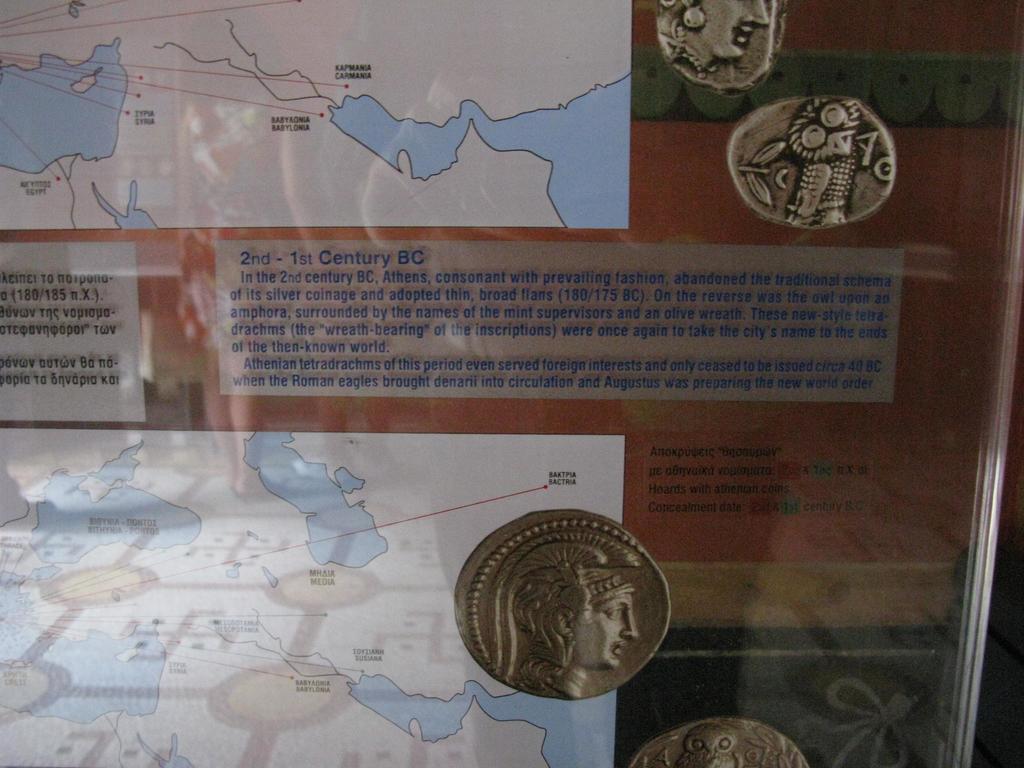What is the time period in blue letters?
Give a very brief answer. Yes. Which city state issued these coins?
Provide a short and direct response. Athens. 